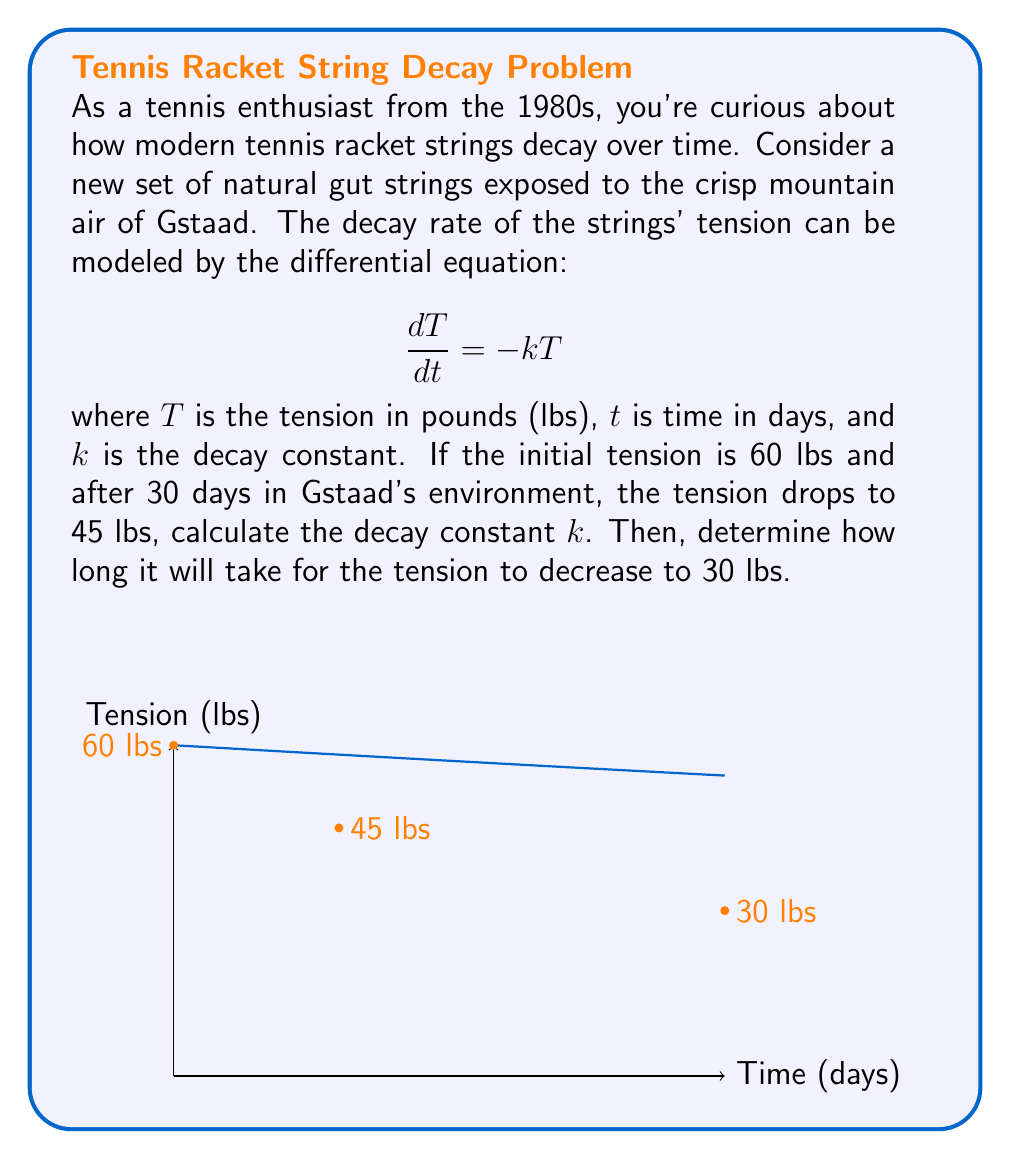Could you help me with this problem? Let's approach this step-by-step:

1) The general solution to the differential equation $\frac{dT}{dt} = -kT$ is:
   $$T(t) = T_0e^{-kt}$$
   where $T_0$ is the initial tension.

2) We know that $T_0 = 60$ lbs and after 30 days, $T(30) = 45$ lbs. Let's substitute these values:
   $$45 = 60e^{-30k}$$

3) Dividing both sides by 60:
   $$\frac{3}{4} = e^{-30k}$$

4) Taking the natural logarithm of both sides:
   $$\ln(\frac{3}{4}) = -30k$$

5) Solving for $k$:
   $$k = -\frac{\ln(\frac{3}{4})}{30} \approx 0.00963\text{ day}^{-1}$$

6) Now that we have $k$, we can find how long it takes for the tension to reach 30 lbs. Let's use the equation from step 1:
   $$30 = 60e^{-0.00963t}$$

7) Dividing both sides by 60:
   $$\frac{1}{2} = e^{-0.00963t}$$

8) Taking the natural logarithm of both sides:
   $$\ln(\frac{1}{2}) = -0.00963t$$

9) Solving for $t$:
   $$t = -\frac{\ln(\frac{1}{2})}{0.00963} \approx 72\text{ days}$$

Therefore, it will take approximately 72 days for the tension to decrease to 30 lbs.
Answer: $k \approx 0.00963\text{ day}^{-1}$; 72 days 